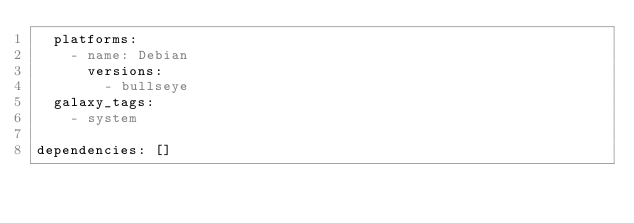<code> <loc_0><loc_0><loc_500><loc_500><_YAML_>  platforms:
    - name: Debian
      versions:
        - bullseye
  galaxy_tags:
    - system

dependencies: []
</code> 